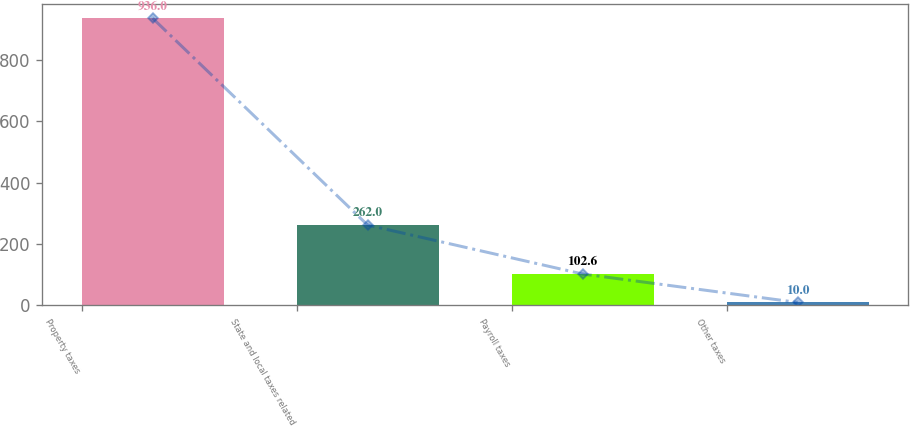Convert chart. <chart><loc_0><loc_0><loc_500><loc_500><bar_chart><fcel>Property taxes<fcel>State and local taxes related<fcel>Payroll taxes<fcel>Other taxes<nl><fcel>936<fcel>262<fcel>102.6<fcel>10<nl></chart> 